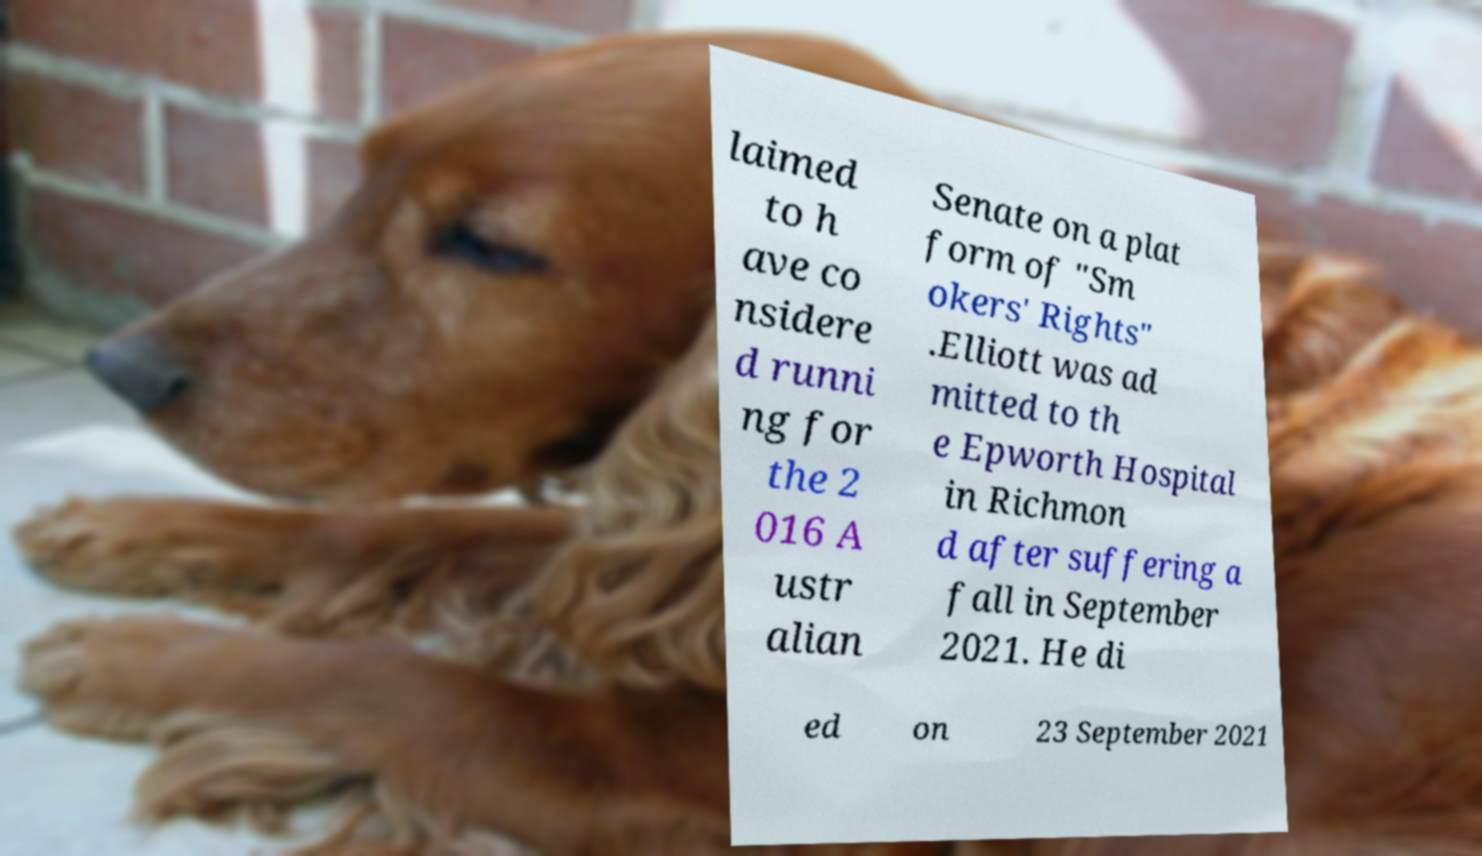Could you assist in decoding the text presented in this image and type it out clearly? laimed to h ave co nsidere d runni ng for the 2 016 A ustr alian Senate on a plat form of "Sm okers' Rights" .Elliott was ad mitted to th e Epworth Hospital in Richmon d after suffering a fall in September 2021. He di ed on 23 September 2021 